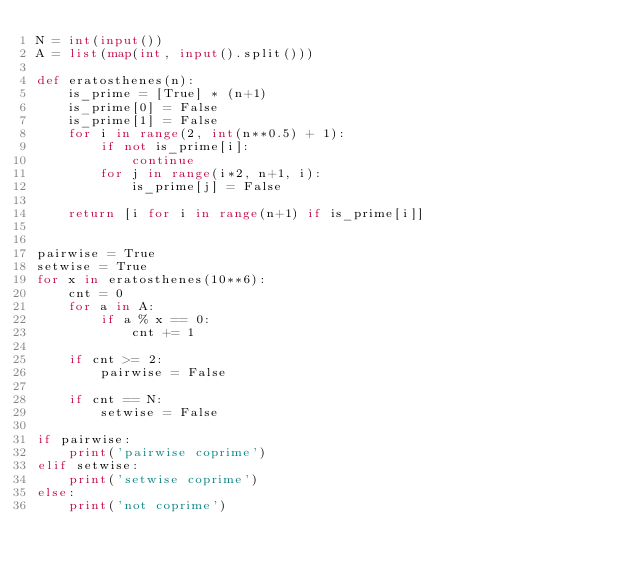<code> <loc_0><loc_0><loc_500><loc_500><_Python_>N = int(input())
A = list(map(int, input().split()))

def eratosthenes(n):
    is_prime = [True] * (n+1)
    is_prime[0] = False
    is_prime[1] = False
    for i in range(2, int(n**0.5) + 1):
        if not is_prime[i]:
            continue
        for j in range(i*2, n+1, i):
            is_prime[j] = False
    
    return [i for i in range(n+1) if is_prime[i]]


pairwise = True
setwise = True
for x in eratosthenes(10**6):
    cnt = 0
    for a in A:
        if a % x == 0:
            cnt += 1
    
    if cnt >= 2:
        pairwise = False
    
    if cnt == N:
        setwise = False
    
if pairwise:
    print('pairwise coprime')
elif setwise:
    print('setwise coprime')
else:
    print('not coprime')
        </code> 